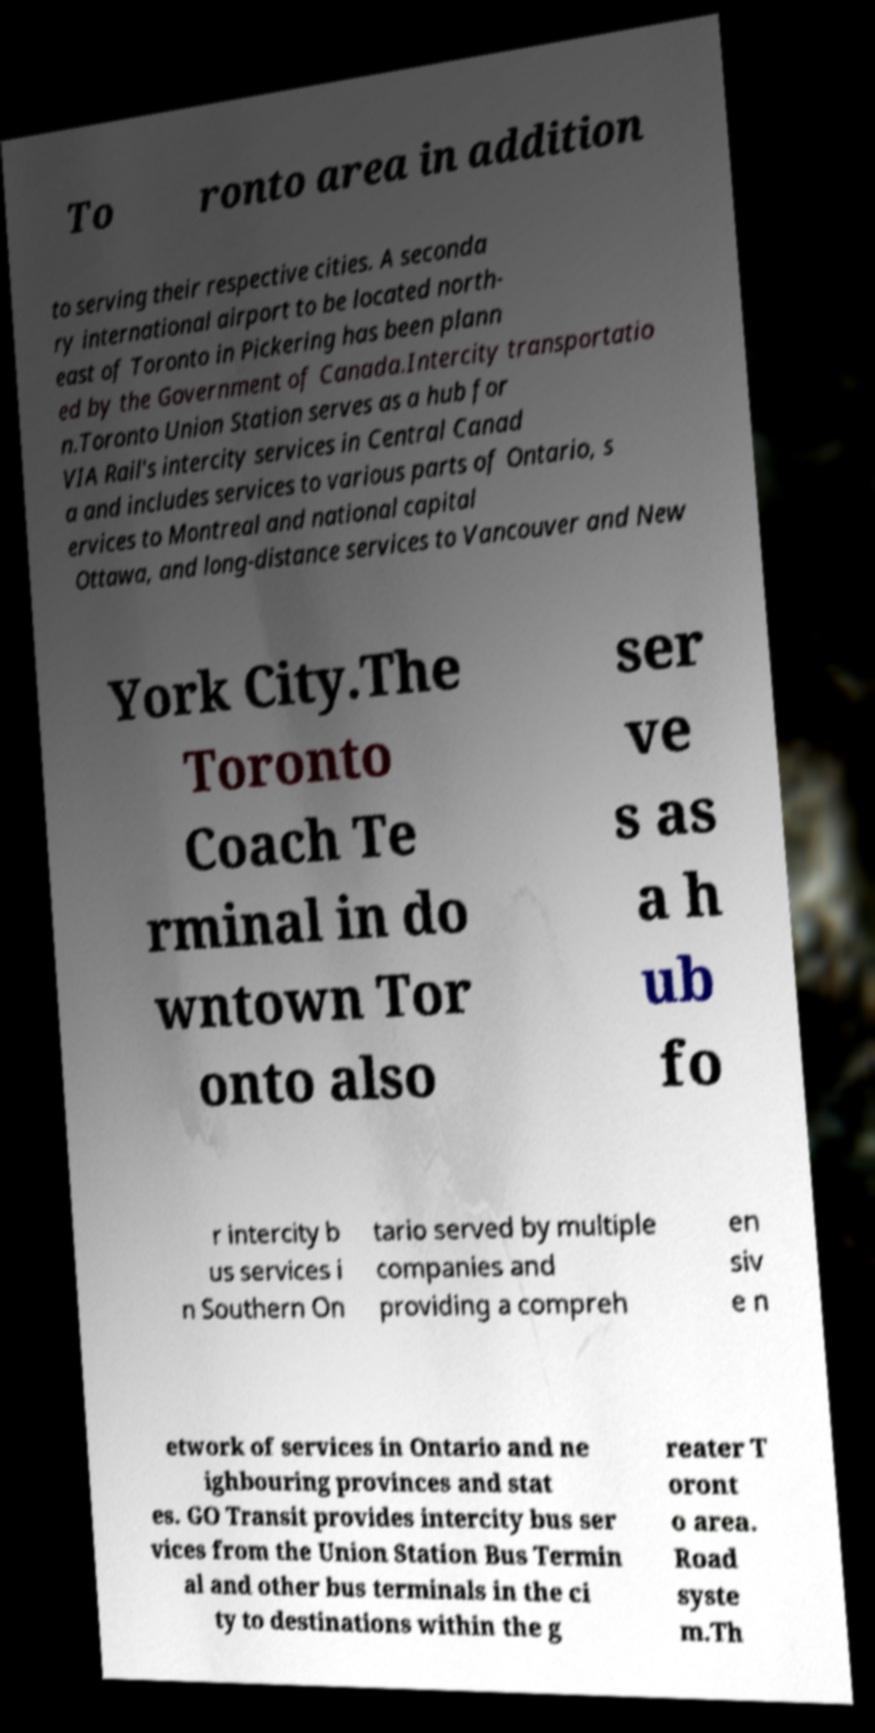Could you assist in decoding the text presented in this image and type it out clearly? To ronto area in addition to serving their respective cities. A seconda ry international airport to be located north- east of Toronto in Pickering has been plann ed by the Government of Canada.Intercity transportatio n.Toronto Union Station serves as a hub for VIA Rail's intercity services in Central Canad a and includes services to various parts of Ontario, s ervices to Montreal and national capital Ottawa, and long-distance services to Vancouver and New York City.The Toronto Coach Te rminal in do wntown Tor onto also ser ve s as a h ub fo r intercity b us services i n Southern On tario served by multiple companies and providing a compreh en siv e n etwork of services in Ontario and ne ighbouring provinces and stat es. GO Transit provides intercity bus ser vices from the Union Station Bus Termin al and other bus terminals in the ci ty to destinations within the g reater T oront o area. Road syste m.Th 